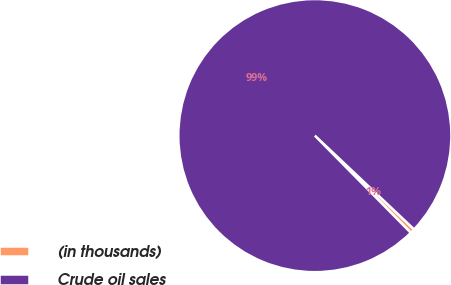Convert chart. <chart><loc_0><loc_0><loc_500><loc_500><pie_chart><fcel>(in thousands)<fcel>Crude oil sales<nl><fcel>0.55%<fcel>99.45%<nl></chart> 